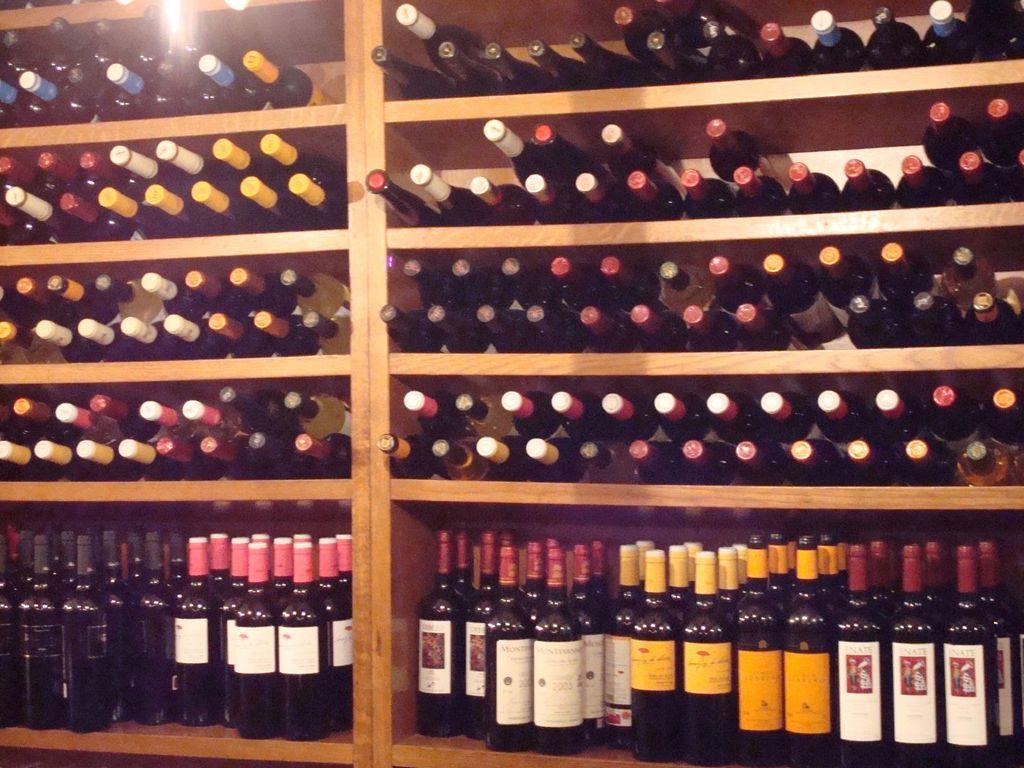Could you give a brief overview of what you see in this image? There is a wine shelf which has many wine bottles placed in it. 